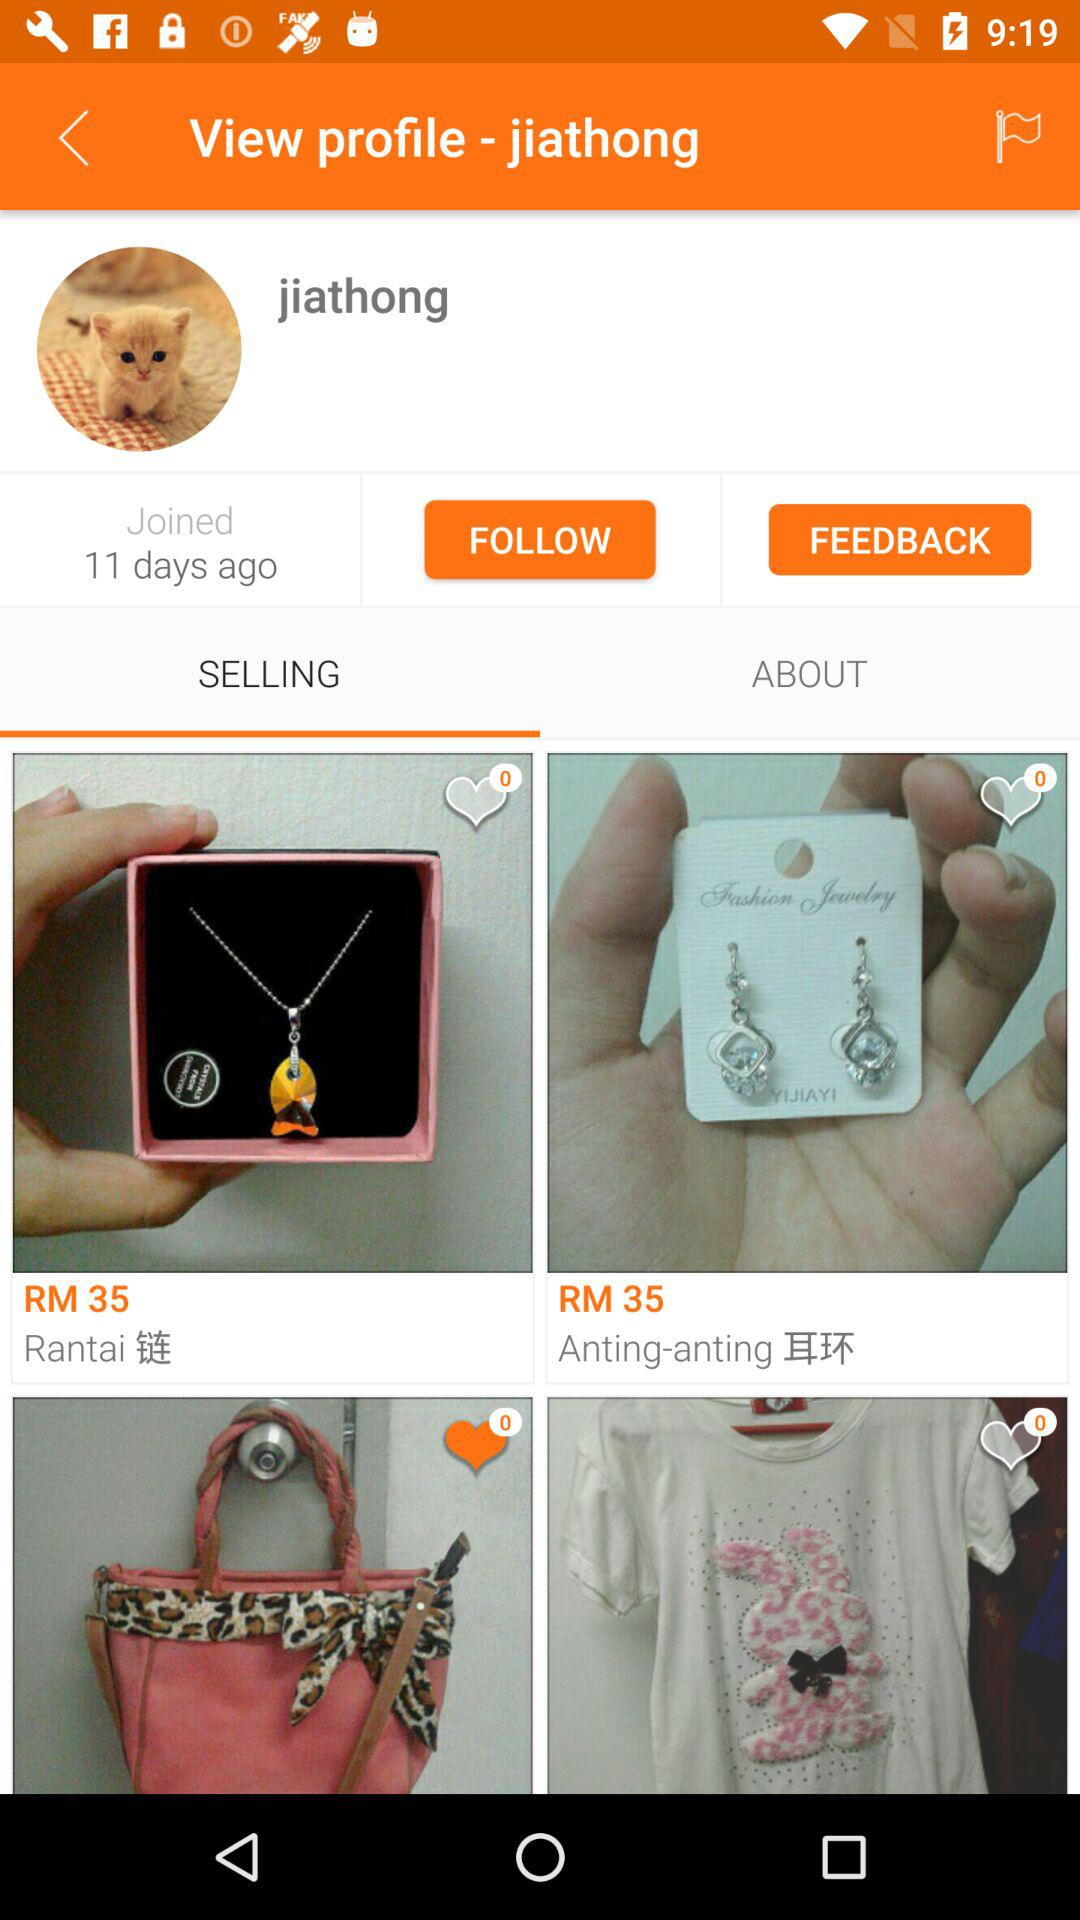Which tab is selected? The selected tab is "SELLING". 